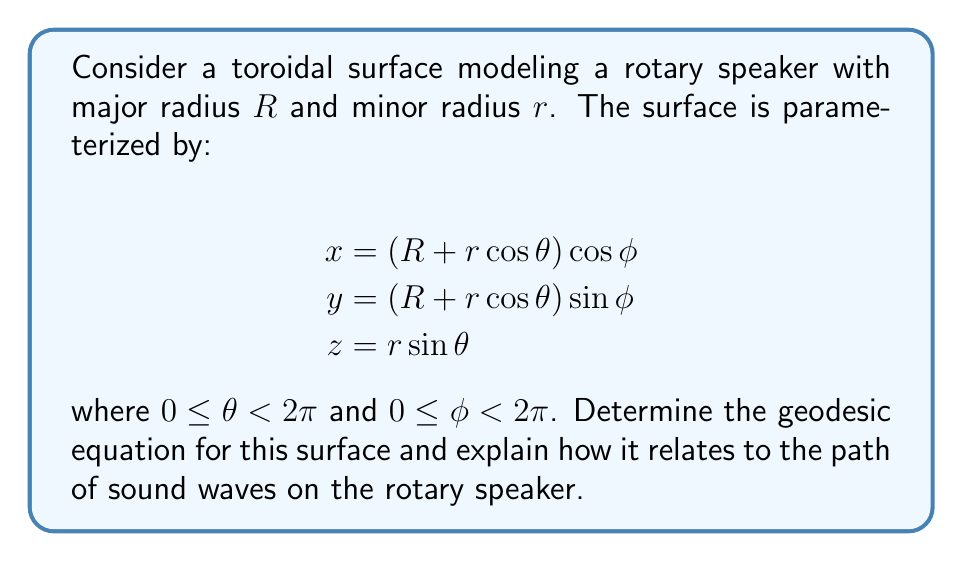Help me with this question. To determine the geodesics on this toroidal surface, we follow these steps:

1. Calculate the metric tensor $g_{ij}$:
   $$g_{11} = r^2$$
   $$g_{12} = g_{21} = 0$$
   $$g_{22} = (R + r\cos\theta)^2$$

2. Compute the Christoffel symbols $\Gamma_{ij}^k$:
   $$\Gamma_{11}^1 = 0$$
   $$\Gamma_{11}^2 = \frac{r\sin\theta}{R + r\cos\theta}$$
   $$\Gamma_{12}^1 = \Gamma_{21}^1 = \frac{R + r\cos\theta}{r}$$
   $$\Gamma_{12}^2 = \Gamma_{21}^2 = 0$$
   $$\Gamma_{22}^1 = 0$$
   $$\Gamma_{22}^2 = -r\sin\theta$$

3. Write the geodesic equations:
   $$\frac{d^2\theta}{ds^2} + \Gamma_{11}^1\left(\frac{d\theta}{ds}\right)^2 + 2\Gamma_{12}^1\frac{d\theta}{ds}\frac{d\phi}{ds} + \Gamma_{22}^1\left(\frac{d\phi}{ds}\right)^2 = 0$$
   $$\frac{d^2\phi}{ds^2} + \Gamma_{11}^2\left(\frac{d\theta}{ds}\right)^2 + 2\Gamma_{12}^2\frac{d\theta}{ds}\frac{d\phi}{ds} + \Gamma_{22}^2\left(\frac{d\phi}{ds}\right)^2 = 0$$

4. Substitute the Christoffel symbols:
   $$\frac{d^2\theta}{ds^2} + 2\frac{R + r\cos\theta}{r}\frac{d\theta}{ds}\frac{d\phi}{ds} = 0$$
   $$\frac{d^2\phi}{ds^2} + \frac{r\sin\theta}{R + r\cos\theta}\left(\frac{d\theta}{ds}\right)^2 - r\sin\theta\left(\frac{d\phi}{ds}\right)^2 = 0$$

These equations describe the geodesics on the toroidal surface. In the context of a rotary speaker, geodesics represent the paths of sound waves that minimize the distance traveled on the surface. This is crucial for understanding how sound propagates and reflects within the speaker, affecting the produced sound's characteristics such as phase, timbre, and spatial distribution.
Answer: $$\begin{cases}
\frac{d^2\theta}{ds^2} + 2\frac{R + r\cos\theta}{r}\frac{d\theta}{ds}\frac{d\phi}{ds} = 0 \\
\frac{d^2\phi}{ds^2} + \frac{r\sin\theta}{R + r\cos\theta}\left(\frac{d\theta}{ds}\right)^2 - r\sin\theta\left(\frac{d\phi}{ds}\right)^2 = 0
\end{cases}$$ 